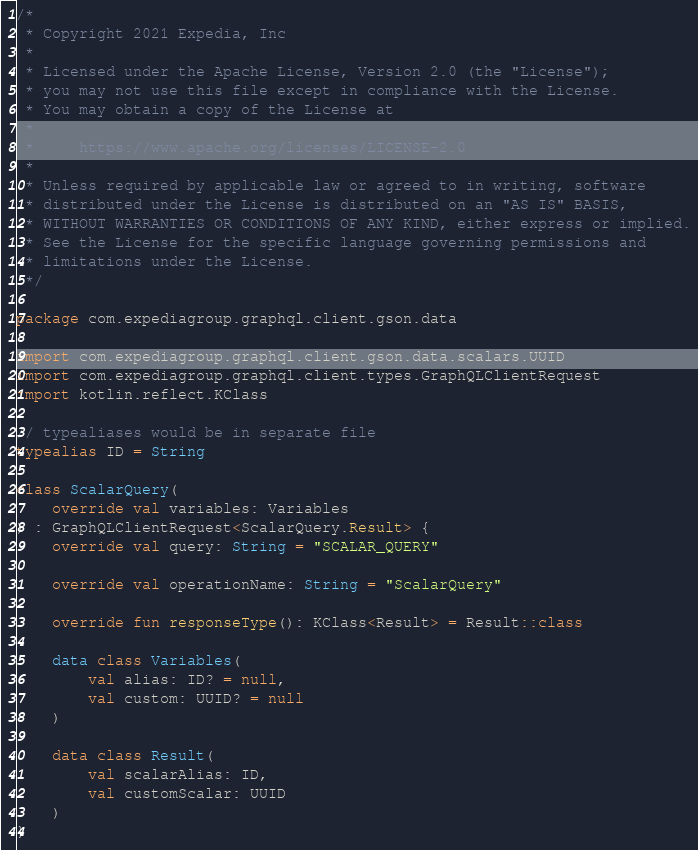Convert code to text. <code><loc_0><loc_0><loc_500><loc_500><_Kotlin_>/*
 * Copyright 2021 Expedia, Inc
 *
 * Licensed under the Apache License, Version 2.0 (the "License");
 * you may not use this file except in compliance with the License.
 * You may obtain a copy of the License at
 *
 *     https://www.apache.org/licenses/LICENSE-2.0
 *
 * Unless required by applicable law or agreed to in writing, software
 * distributed under the License is distributed on an "AS IS" BASIS,
 * WITHOUT WARRANTIES OR CONDITIONS OF ANY KIND, either express or implied.
 * See the License for the specific language governing permissions and
 * limitations under the License.
 */

package com.expediagroup.graphql.client.gson.data

import com.expediagroup.graphql.client.gson.data.scalars.UUID
import com.expediagroup.graphql.client.types.GraphQLClientRequest
import kotlin.reflect.KClass

// typealiases would be in separate file
typealias ID = String

class ScalarQuery(
    override val variables: Variables
) : GraphQLClientRequest<ScalarQuery.Result> {
    override val query: String = "SCALAR_QUERY"

    override val operationName: String = "ScalarQuery"

    override fun responseType(): KClass<Result> = Result::class

    data class Variables(
        val alias: ID? = null,
        val custom: UUID? = null
    )

    data class Result(
        val scalarAlias: ID,
        val customScalar: UUID
    )
}
</code> 